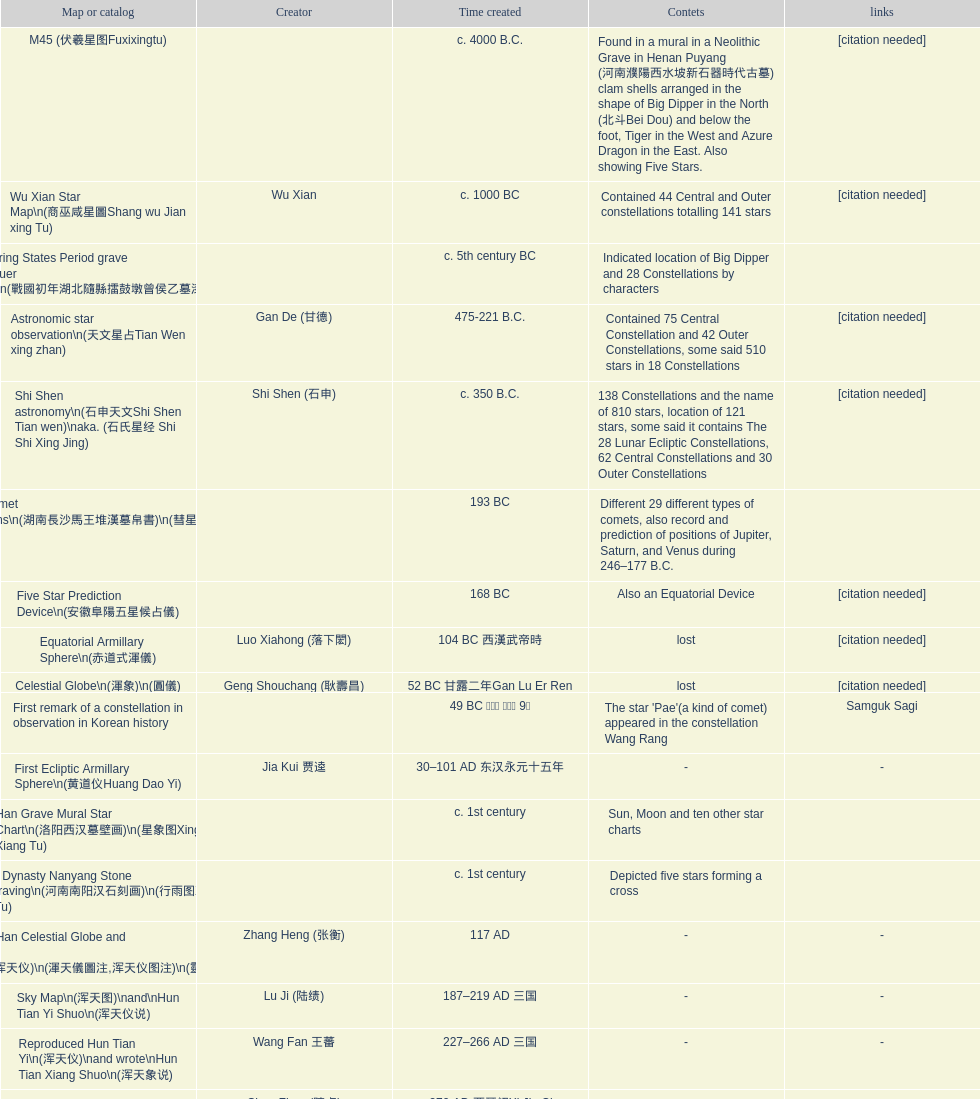List three inventions that emerged soon after the equatorial armillary sphere. Celestial Globe (渾象) (圓儀), First remark of a constellation in observation in Korean history, First Ecliptic Armillary Sphere (黄道仪Huang Dao Yi). 